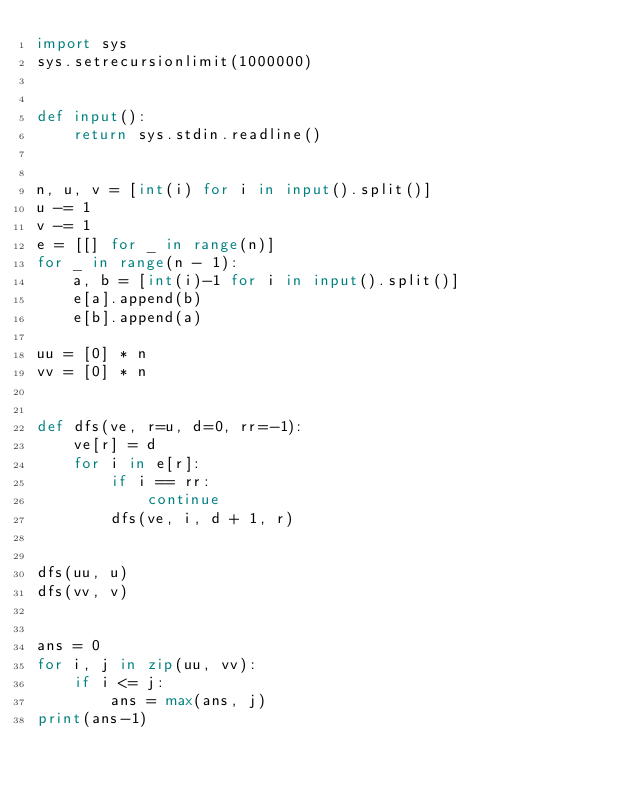<code> <loc_0><loc_0><loc_500><loc_500><_Python_>import sys
sys.setrecursionlimit(1000000)


def input():
    return sys.stdin.readline()


n, u, v = [int(i) for i in input().split()]
u -= 1
v -= 1
e = [[] for _ in range(n)]
for _ in range(n - 1):
    a, b = [int(i)-1 for i in input().split()]
    e[a].append(b)
    e[b].append(a)

uu = [0] * n
vv = [0] * n


def dfs(ve, r=u, d=0, rr=-1):
    ve[r] = d
    for i in e[r]:
        if i == rr:
            continue
        dfs(ve, i, d + 1, r)


dfs(uu, u)
dfs(vv, v)


ans = 0
for i, j in zip(uu, vv):
    if i <= j:
        ans = max(ans, j)
print(ans-1)
</code> 